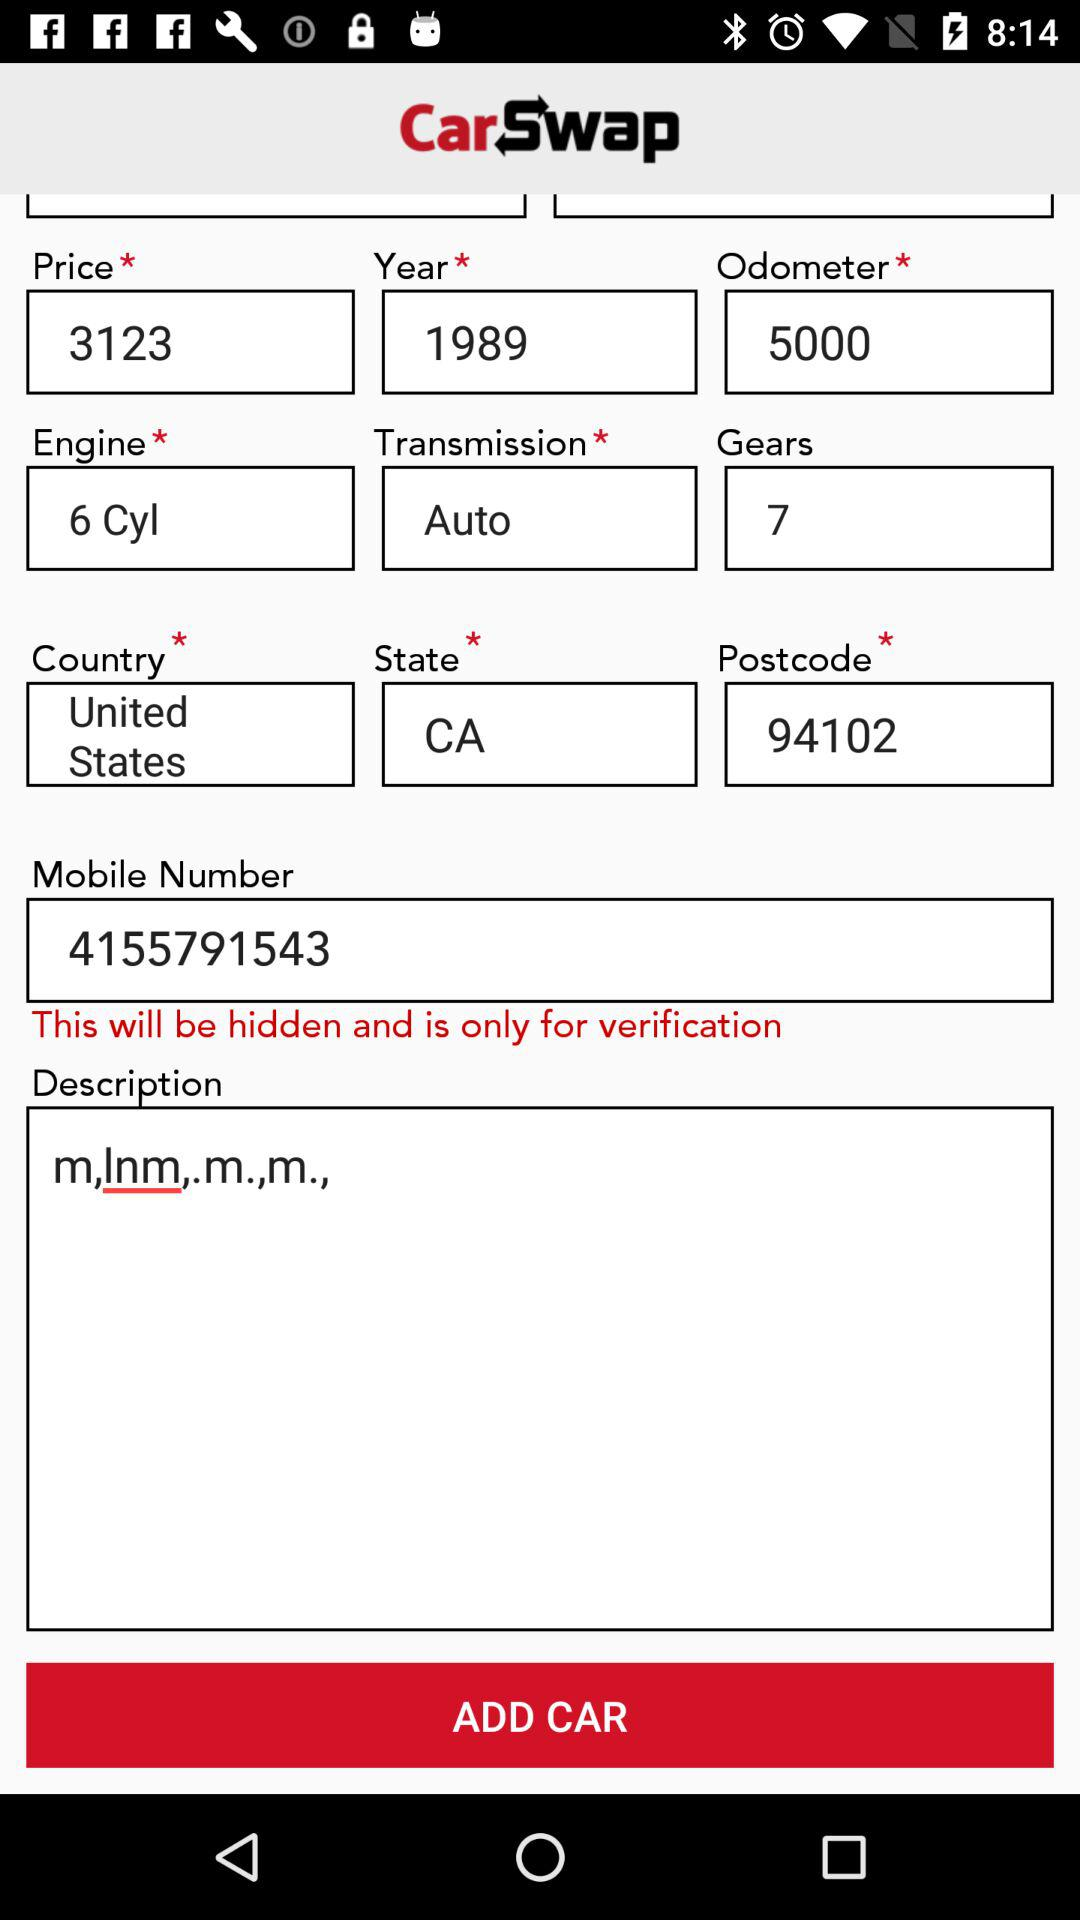What is the postcode of the user? The postcode of the user is 94102. 